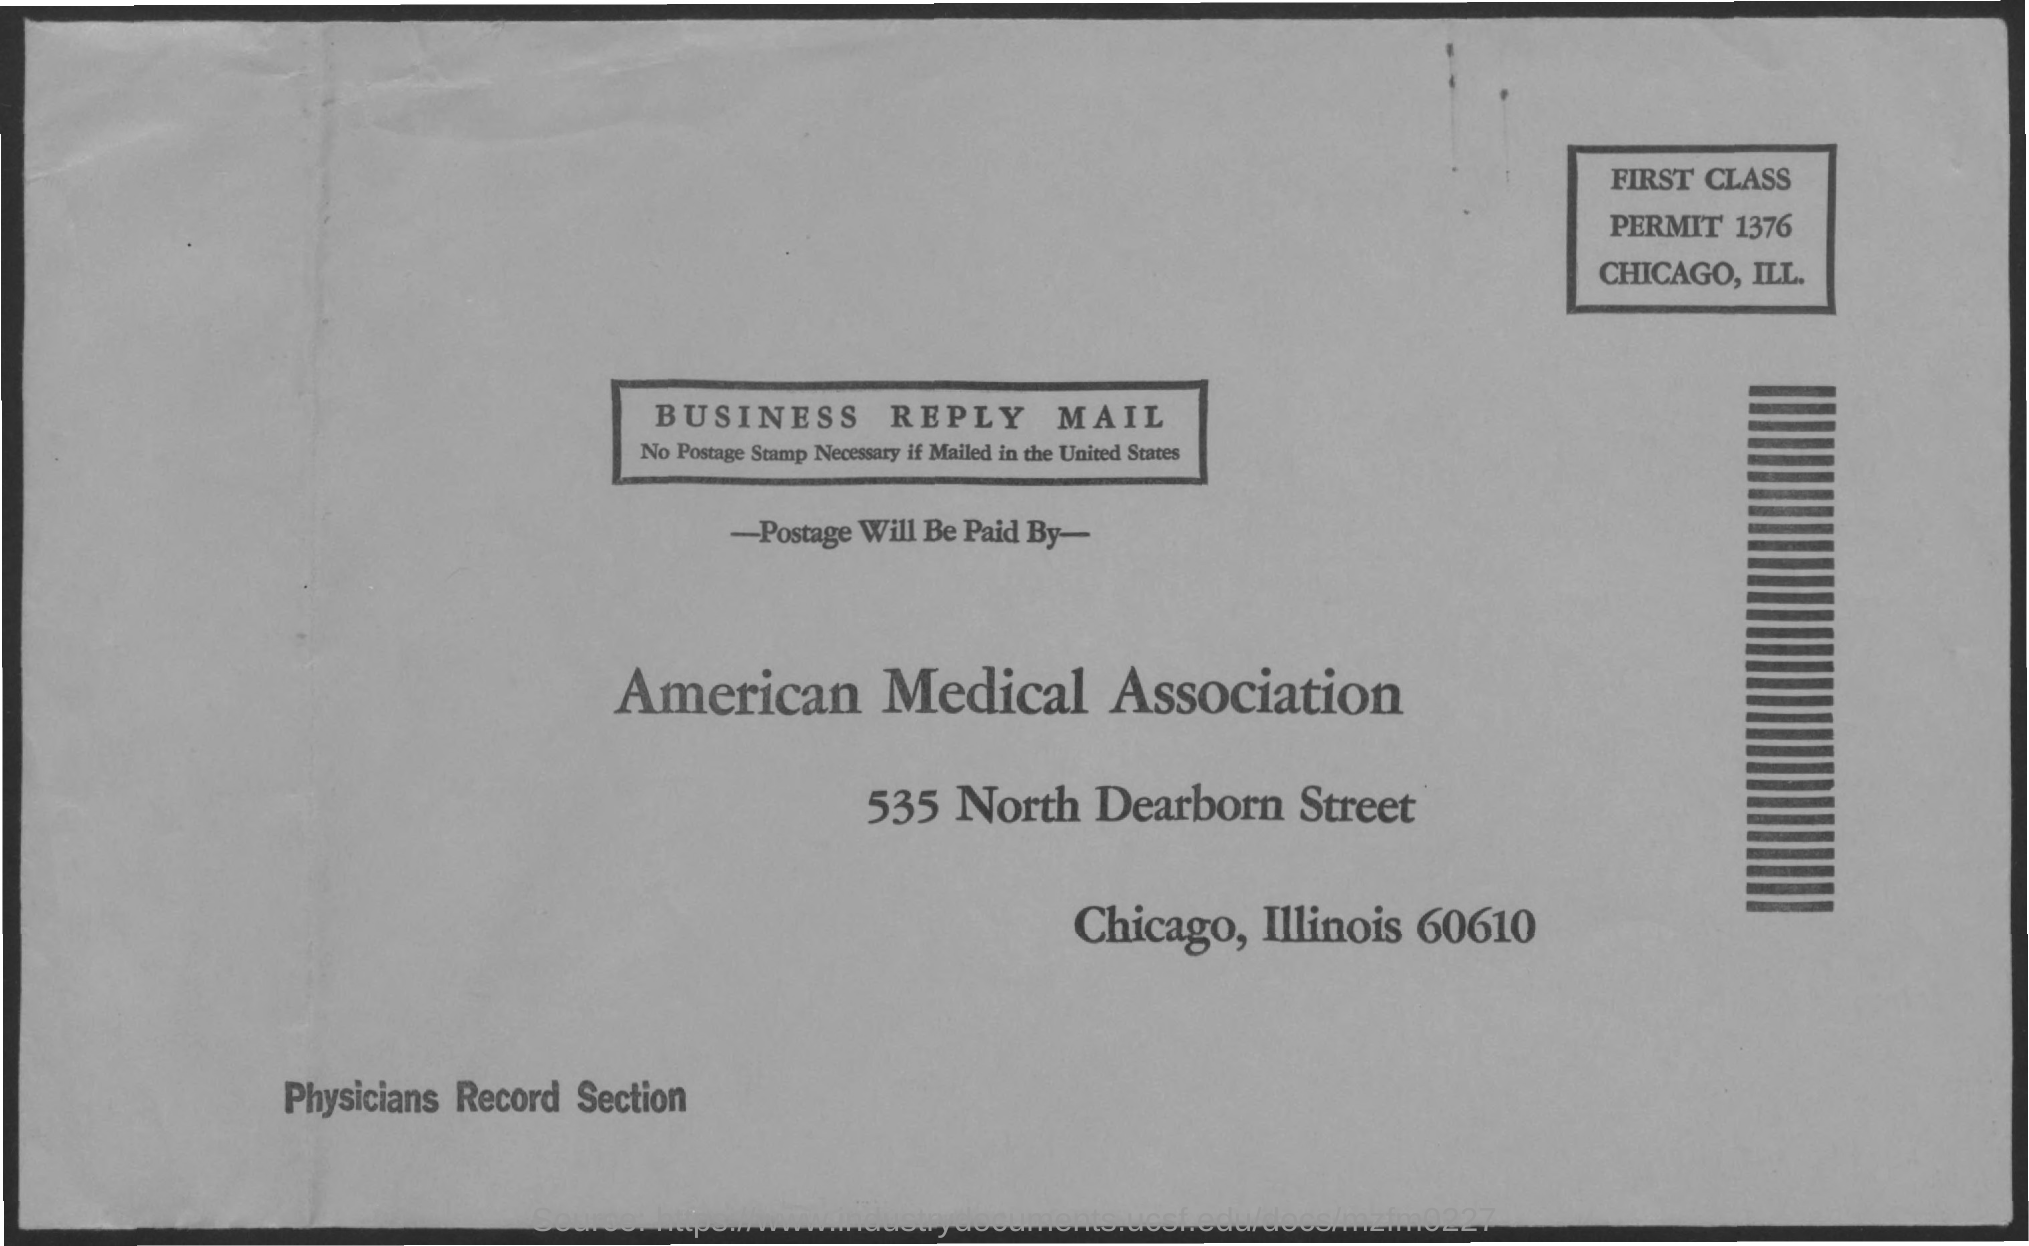Outline some significant characteristics in this image. I have a first-class permit number, and it is 1376... 